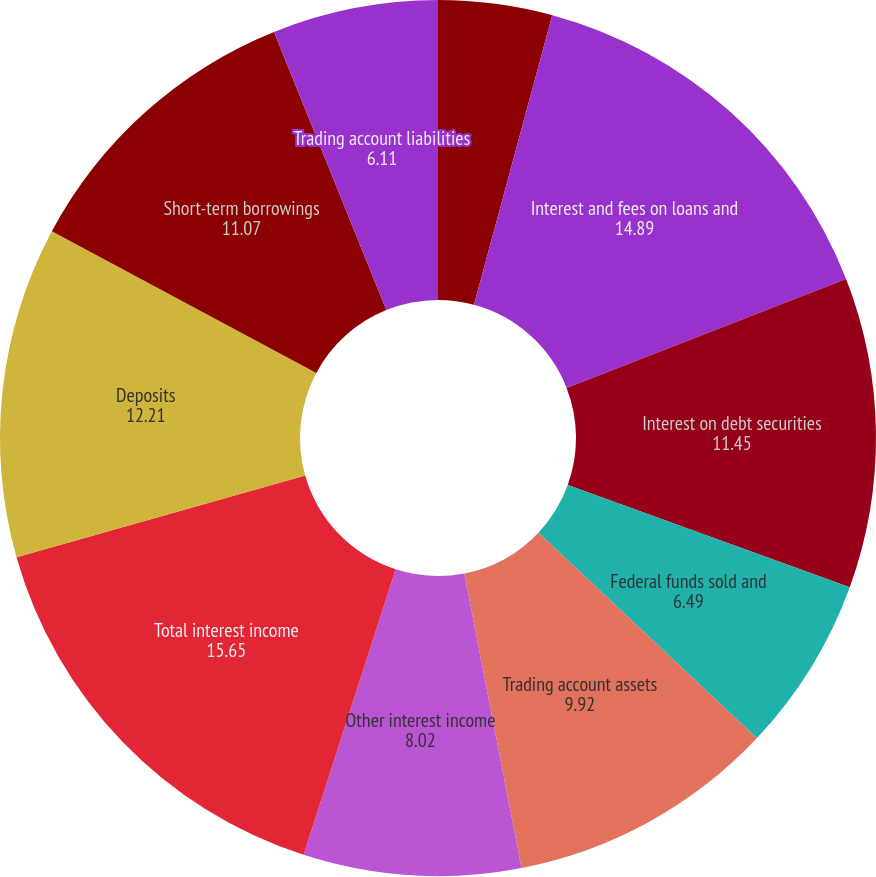Convert chart. <chart><loc_0><loc_0><loc_500><loc_500><pie_chart><fcel>(Dollars in millions except<fcel>Interest and fees on loans and<fcel>Interest on debt securities<fcel>Federal funds sold and<fcel>Trading account assets<fcel>Other interest income<fcel>Total interest income<fcel>Deposits<fcel>Short-term borrowings<fcel>Trading account liabilities<nl><fcel>4.2%<fcel>14.89%<fcel>11.45%<fcel>6.49%<fcel>9.92%<fcel>8.02%<fcel>15.65%<fcel>12.21%<fcel>11.07%<fcel>6.11%<nl></chart> 